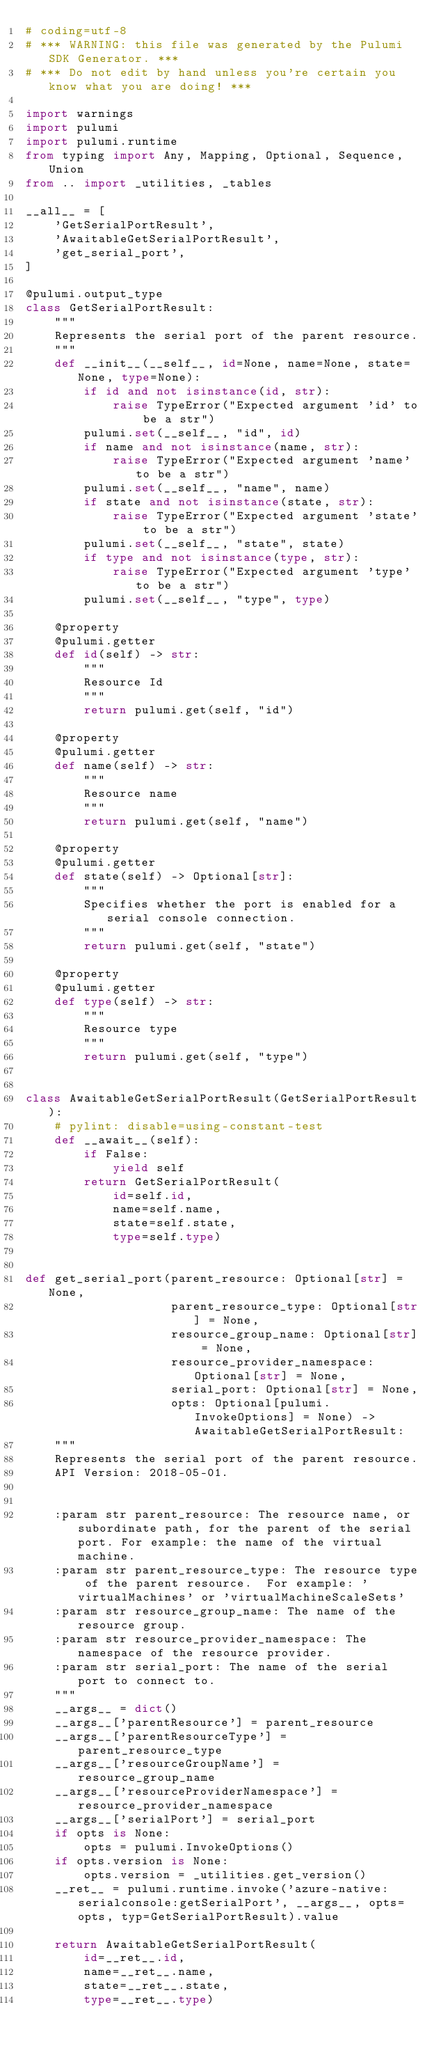Convert code to text. <code><loc_0><loc_0><loc_500><loc_500><_Python_># coding=utf-8
# *** WARNING: this file was generated by the Pulumi SDK Generator. ***
# *** Do not edit by hand unless you're certain you know what you are doing! ***

import warnings
import pulumi
import pulumi.runtime
from typing import Any, Mapping, Optional, Sequence, Union
from .. import _utilities, _tables

__all__ = [
    'GetSerialPortResult',
    'AwaitableGetSerialPortResult',
    'get_serial_port',
]

@pulumi.output_type
class GetSerialPortResult:
    """
    Represents the serial port of the parent resource.
    """
    def __init__(__self__, id=None, name=None, state=None, type=None):
        if id and not isinstance(id, str):
            raise TypeError("Expected argument 'id' to be a str")
        pulumi.set(__self__, "id", id)
        if name and not isinstance(name, str):
            raise TypeError("Expected argument 'name' to be a str")
        pulumi.set(__self__, "name", name)
        if state and not isinstance(state, str):
            raise TypeError("Expected argument 'state' to be a str")
        pulumi.set(__self__, "state", state)
        if type and not isinstance(type, str):
            raise TypeError("Expected argument 'type' to be a str")
        pulumi.set(__self__, "type", type)

    @property
    @pulumi.getter
    def id(self) -> str:
        """
        Resource Id
        """
        return pulumi.get(self, "id")

    @property
    @pulumi.getter
    def name(self) -> str:
        """
        Resource name
        """
        return pulumi.get(self, "name")

    @property
    @pulumi.getter
    def state(self) -> Optional[str]:
        """
        Specifies whether the port is enabled for a serial console connection.
        """
        return pulumi.get(self, "state")

    @property
    @pulumi.getter
    def type(self) -> str:
        """
        Resource type
        """
        return pulumi.get(self, "type")


class AwaitableGetSerialPortResult(GetSerialPortResult):
    # pylint: disable=using-constant-test
    def __await__(self):
        if False:
            yield self
        return GetSerialPortResult(
            id=self.id,
            name=self.name,
            state=self.state,
            type=self.type)


def get_serial_port(parent_resource: Optional[str] = None,
                    parent_resource_type: Optional[str] = None,
                    resource_group_name: Optional[str] = None,
                    resource_provider_namespace: Optional[str] = None,
                    serial_port: Optional[str] = None,
                    opts: Optional[pulumi.InvokeOptions] = None) -> AwaitableGetSerialPortResult:
    """
    Represents the serial port of the parent resource.
    API Version: 2018-05-01.


    :param str parent_resource: The resource name, or subordinate path, for the parent of the serial port. For example: the name of the virtual machine.
    :param str parent_resource_type: The resource type of the parent resource.  For example: 'virtualMachines' or 'virtualMachineScaleSets'
    :param str resource_group_name: The name of the resource group.
    :param str resource_provider_namespace: The namespace of the resource provider.
    :param str serial_port: The name of the serial port to connect to.
    """
    __args__ = dict()
    __args__['parentResource'] = parent_resource
    __args__['parentResourceType'] = parent_resource_type
    __args__['resourceGroupName'] = resource_group_name
    __args__['resourceProviderNamespace'] = resource_provider_namespace
    __args__['serialPort'] = serial_port
    if opts is None:
        opts = pulumi.InvokeOptions()
    if opts.version is None:
        opts.version = _utilities.get_version()
    __ret__ = pulumi.runtime.invoke('azure-native:serialconsole:getSerialPort', __args__, opts=opts, typ=GetSerialPortResult).value

    return AwaitableGetSerialPortResult(
        id=__ret__.id,
        name=__ret__.name,
        state=__ret__.state,
        type=__ret__.type)
</code> 